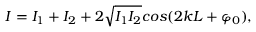Convert formula to latex. <formula><loc_0><loc_0><loc_500><loc_500>I = I _ { 1 } + I _ { 2 } + 2 \sqrt { I _ { 1 } I _ { 2 } } \cos ( 2 k L + \varphi _ { 0 } ) ,</formula> 